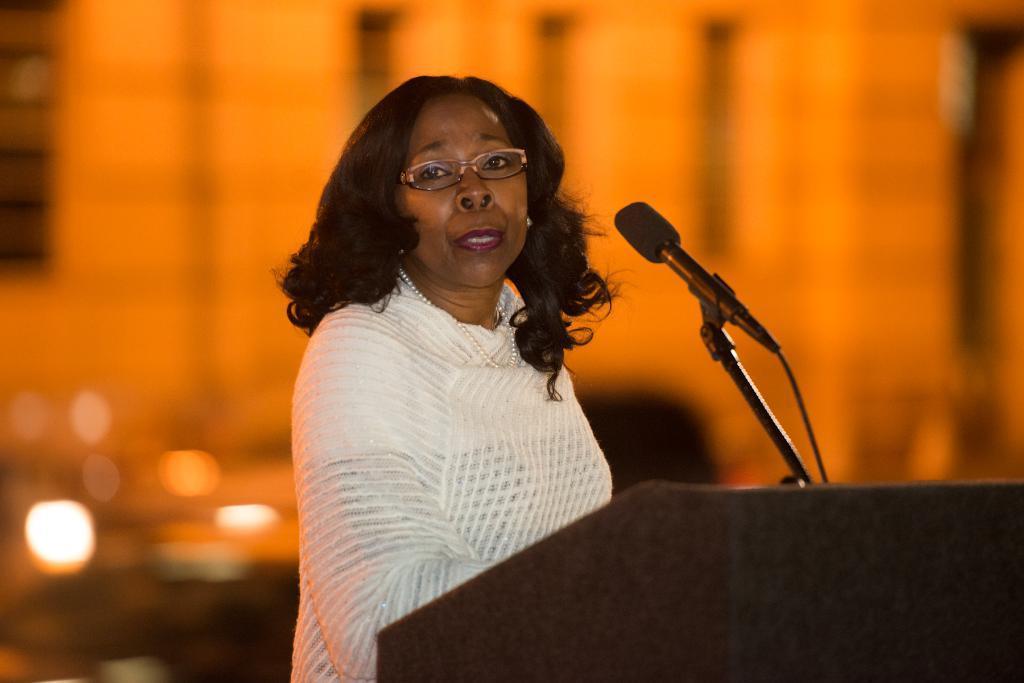Could you give a brief overview of what you see in this image? In this image we can see a woman, mike and podium. 